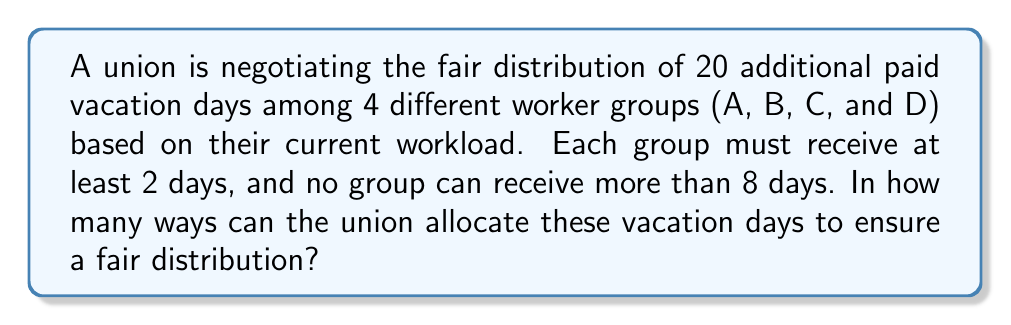Provide a solution to this math problem. Let's approach this step-by-step using the stars and bars method with restrictions:

1) First, we need to account for the minimum 2 days each group must receive:
   $20 - (2 \times 4) = 12$ days left to distribute

2) Now, we need to find the number of ways to distribute 12 days among 4 groups, with each group receiving at most 6 additional days (since 8 - 2 = 6).

3) This is equivalent to finding the number of solutions to the equation:
   $x_1 + x_2 + x_3 + x_4 = 12$, where $0 \leq x_i \leq 6$ for $i = 1,2,3,4$

4) We can use the generating function approach:
   $$(1 + x + x^2 + x^3 + x^4 + x^5 + x^6)^4$$

5) The coefficient of $x^{12}$ in this expansion will give us the number of ways to distribute the days.

6) Using the stars and bars formula with restrictions:
   $$\sum_{k=0}^4 (-1)^k \binom{4}{k} \binom{12 + 4 - 1 - 7k}{4 - 1}$$

7) Expanding this:
   $\binom{4}{0}\binom{15}{3} - \binom{4}{1}\binom{8}{3} + \binom{4}{2}\binom{1}{3} - \binom{4}{3}\binom{-6}{3} + \binom{4}{4}\binom{-13}{3}$

8) Calculating:
   $1 \times 455 - 4 \times 56 + 6 \times 0 - 4 \times 0 + 1 \times 0 = 455 - 224 = 231$

Therefore, there are 231 ways to allocate the vacation days fairly.
Answer: 231 